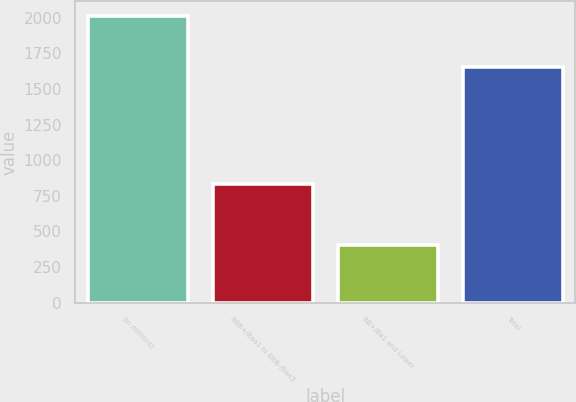Convert chart to OTSL. <chart><loc_0><loc_0><loc_500><loc_500><bar_chart><fcel>(in millions)<fcel>BBB+/Baa1 to BBB-/Baa3<fcel>BB+/Ba1 and Lower<fcel>Total<nl><fcel>2014<fcel>833<fcel>406<fcel>1656<nl></chart> 